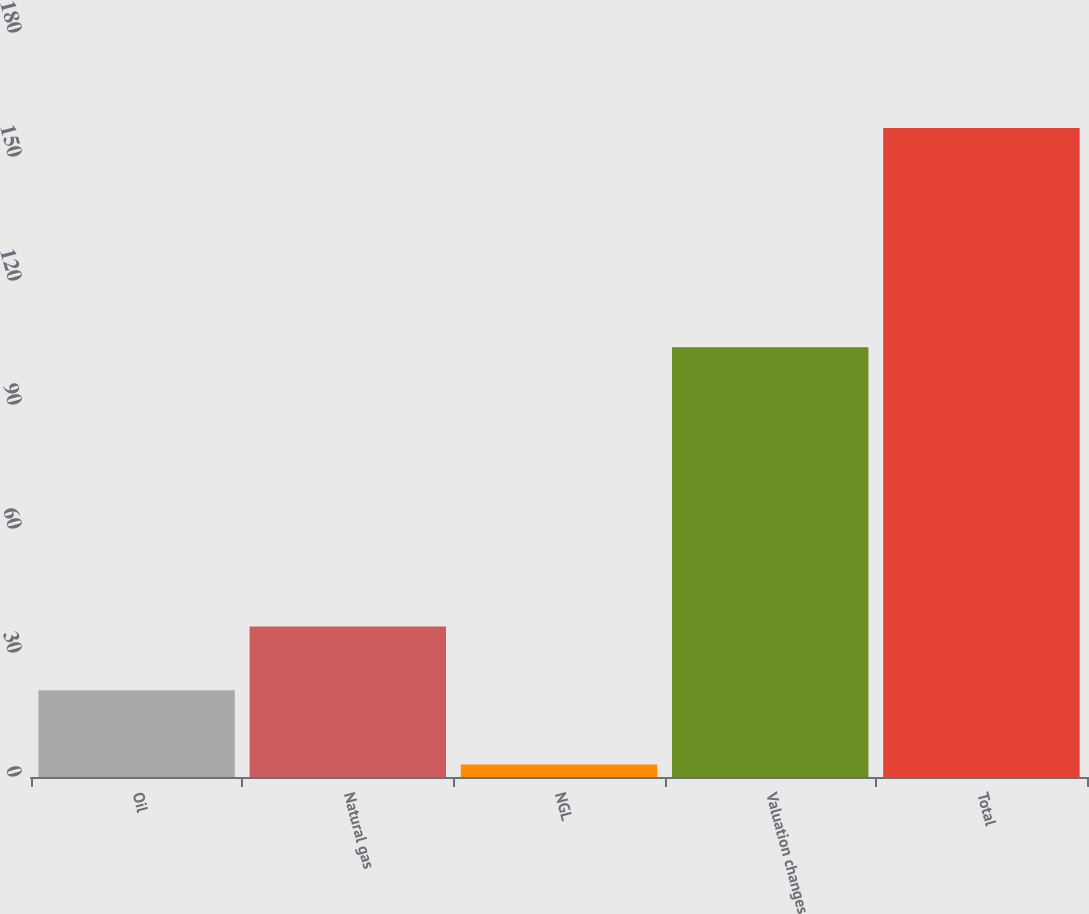Convert chart. <chart><loc_0><loc_0><loc_500><loc_500><bar_chart><fcel>Oil<fcel>Natural gas<fcel>NGL<fcel>Valuation changes<fcel>Total<nl><fcel>21<fcel>36.4<fcel>3<fcel>104<fcel>157<nl></chart> 